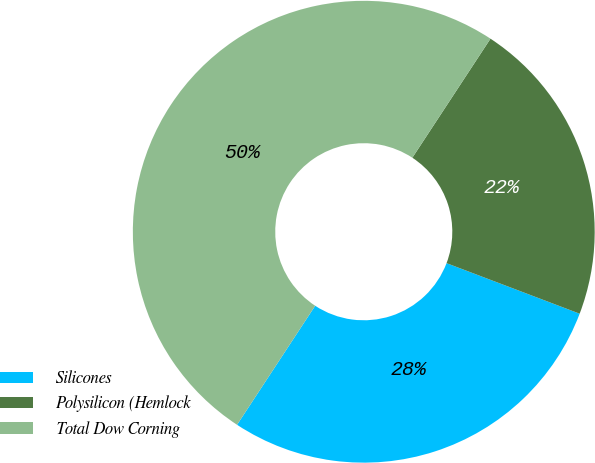<chart> <loc_0><loc_0><loc_500><loc_500><pie_chart><fcel>Silicones<fcel>Polysilicon (Hemlock<fcel>Total Dow Corning<nl><fcel>28.47%<fcel>21.53%<fcel>50.0%<nl></chart> 